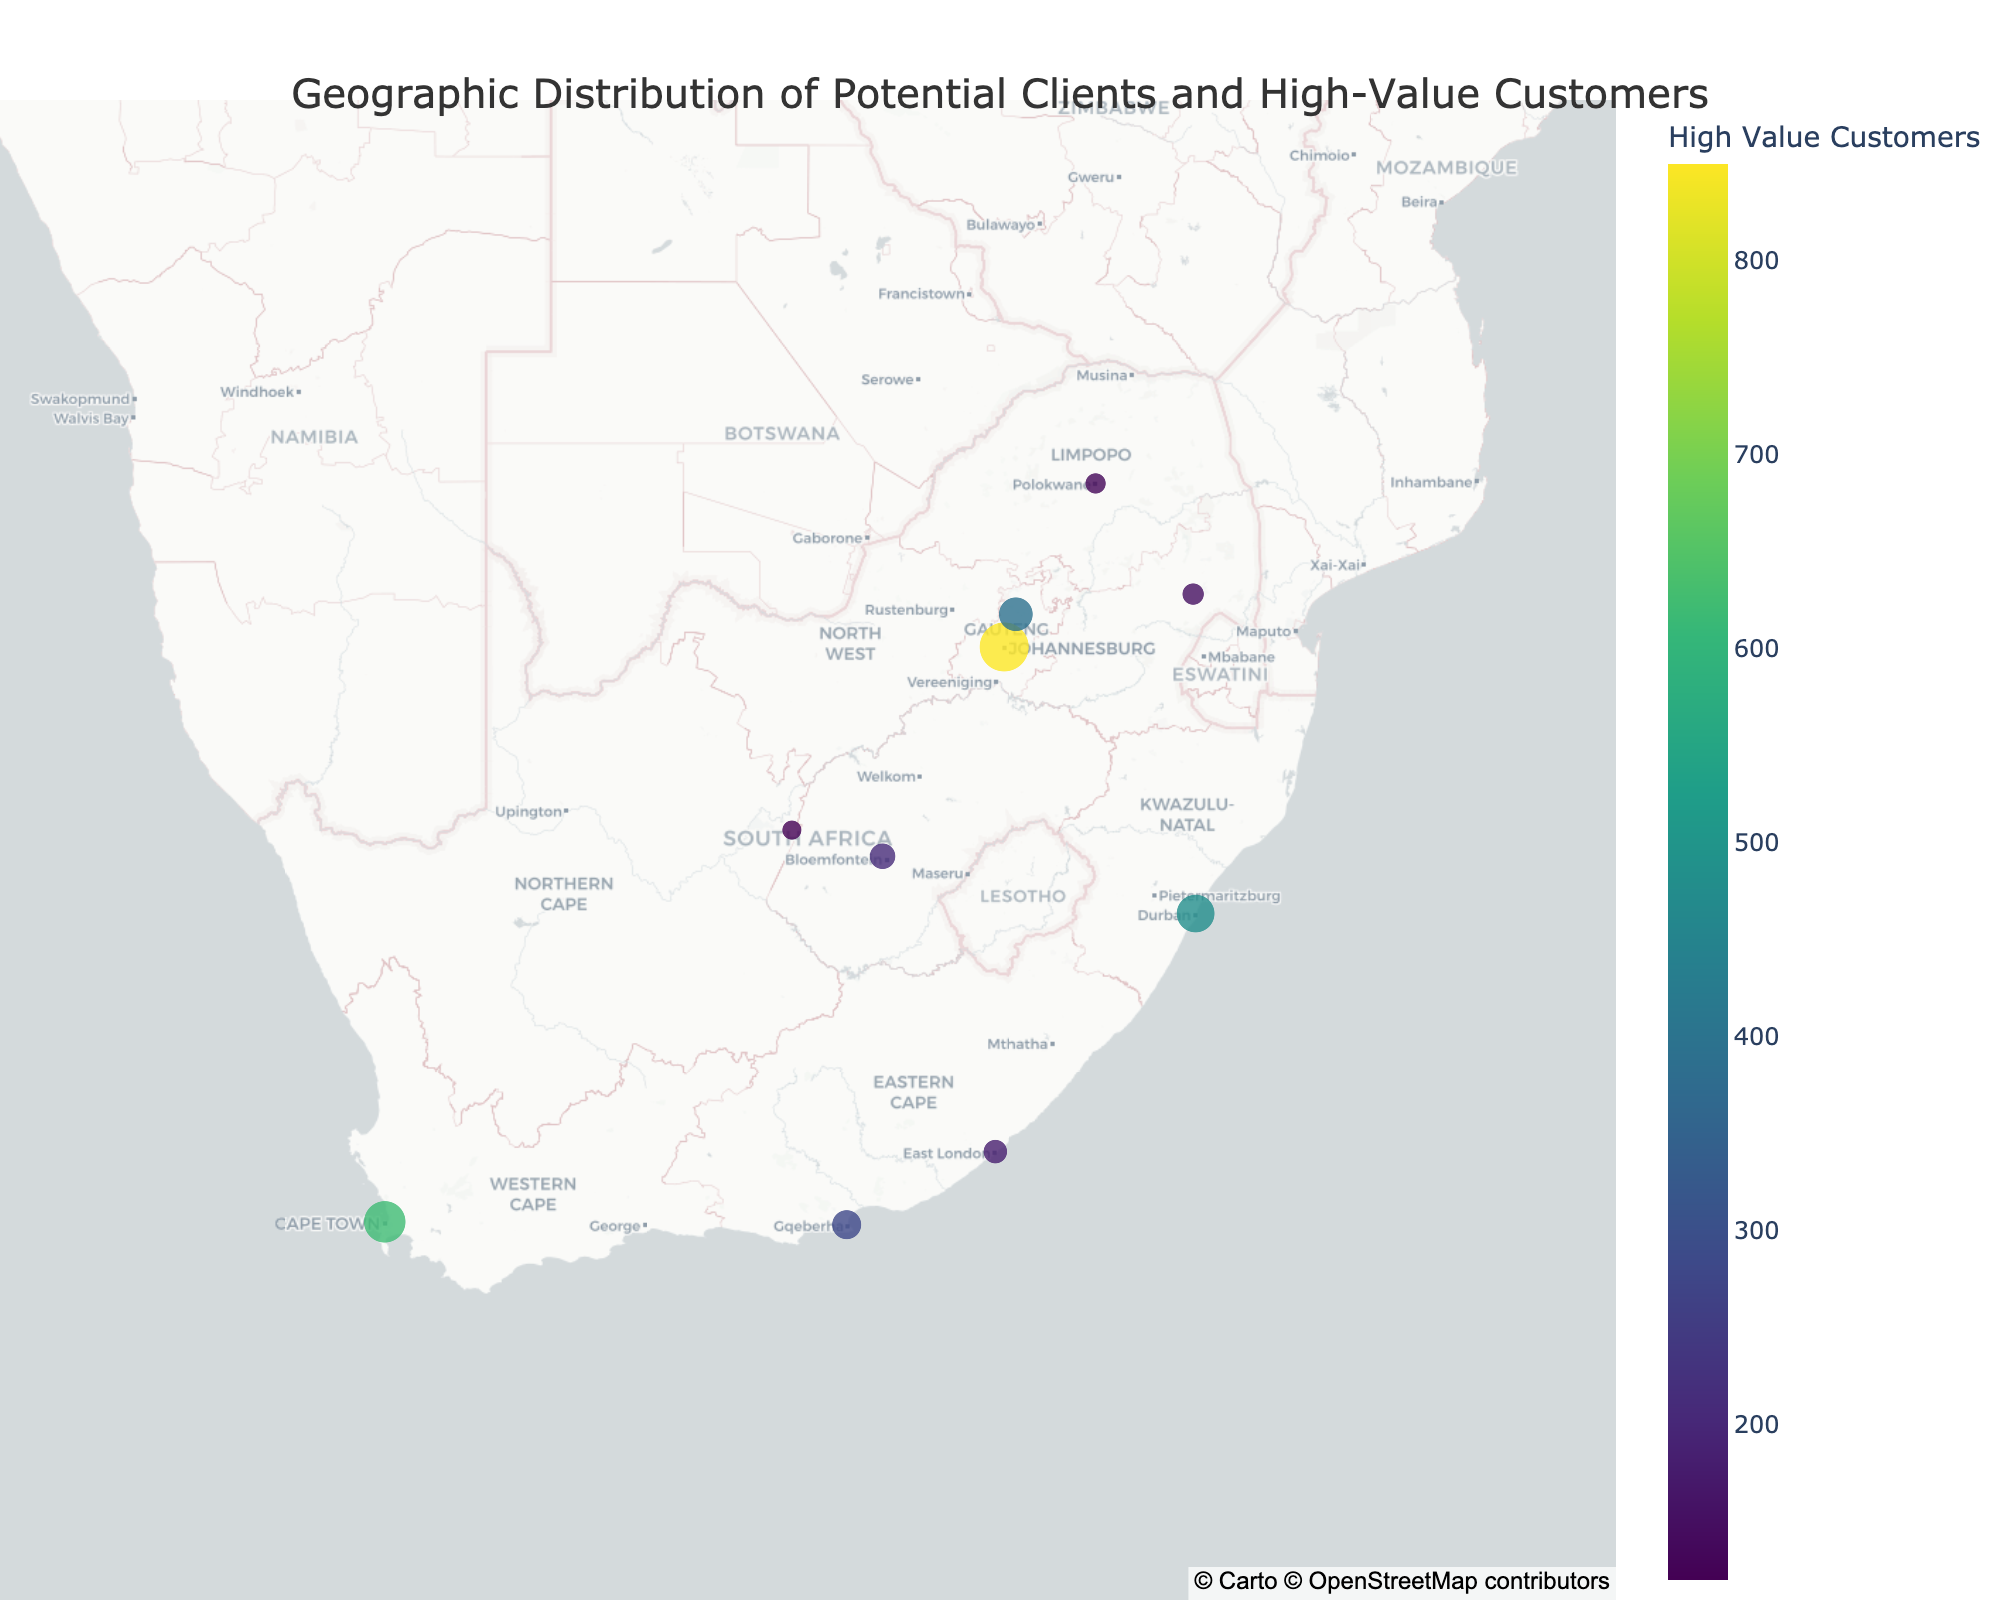What's the title of the figure? The title is located at the top of the figure. It provides an overview of what the figure represents. By looking at the top, we see the text "Geographic Distribution of Potential Clients and High-Value Customers."
Answer: Geographic Distribution of Potential Clients and High-Value Customers Which city has the highest number of potential clients? By examining the plot, we can see that the size of the markers indicates the number of potential clients. The largest marker corresponds to Johannesburg, indicating it has the highest number of potential clients.
Answer: Johannesburg What color scale is used for representing high-value customers? The color of the markers represents the high-value customers, and the color scale is shown in the color bar. Observing the color bar, we see that the "Viridis" color scale ranges from dark blue to yellow.
Answer: Viridis Which city has more high-value customers, Cape Town or Durban? By comparing the colors of the markers for Cape Town and Durban, we find that Cape Town has a lighter color. Checking the color bar, a lighter color means a higher value. The numerical values support this, with Cape Town at 620 and Durban at 480.
Answer: Cape Town What's the combined total of high-value customers in Pretoria and Bloemfontein? First, note the high-value customers for Pretoria (390) and Bloemfontein (210). Adding these together gives 390 + 210.
Answer: 600 How does the size of the marker change with the number of potential clients? Observing the figure, it's noticeable that larger markers correspond to cities with more potential clients. The size is proportional to the square root of the number of potential clients, divided by 2, which is why markers with larger numbers of potential clients appear larger.
Answer: Proportional to the square root of potential clients Which city in the Eastern Cape province has more high-value customers? Both Port Elizabeth and East London are in the Eastern Cape province. Comparing their marker colors and numbers, Port Elizabeth has a value of 280 while East London has 180.
Answer: Port Elizabeth What relationship could you infer between the size of the markers and business opportunities? Larger markers indicate a higher number of potential clients. This suggests that cities with larger markers have more business opportunities due to a larger client base. By focusing on cities with larger markers, business strategies can be optimized to target areas with more potential clients.
Answer: Larger markers suggest more business opportunities Which two cities have the smallest markers, and how many potential clients do they have? By examining the figure, the smallest markers are for Polokwane and Kimberley. Checking the numerical values, Polokwane has 450 potential clients and Kimberley has 400.
Answer: Polokwane and Kimberley What is the geographic center of the map? The center of the map is determined by the latitude and longitude values set in the mapbox center property. Observing the figure, the center is given by the values (lat=-29, lon=25).
Answer: Latitude -29, Longitude 25 